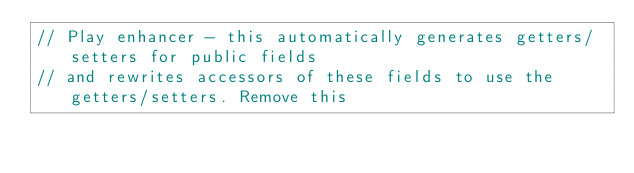<code> <loc_0><loc_0><loc_500><loc_500><_Scala_>// Play enhancer - this automatically generates getters/setters for public fields
// and rewrites accessors of these fields to use the getters/setters. Remove this</code> 